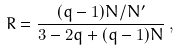<formula> <loc_0><loc_0><loc_500><loc_500>R = \frac { ( q - 1 ) N / N ^ { \prime } } { 3 - 2 q + ( q - 1 ) N } \, ,</formula> 